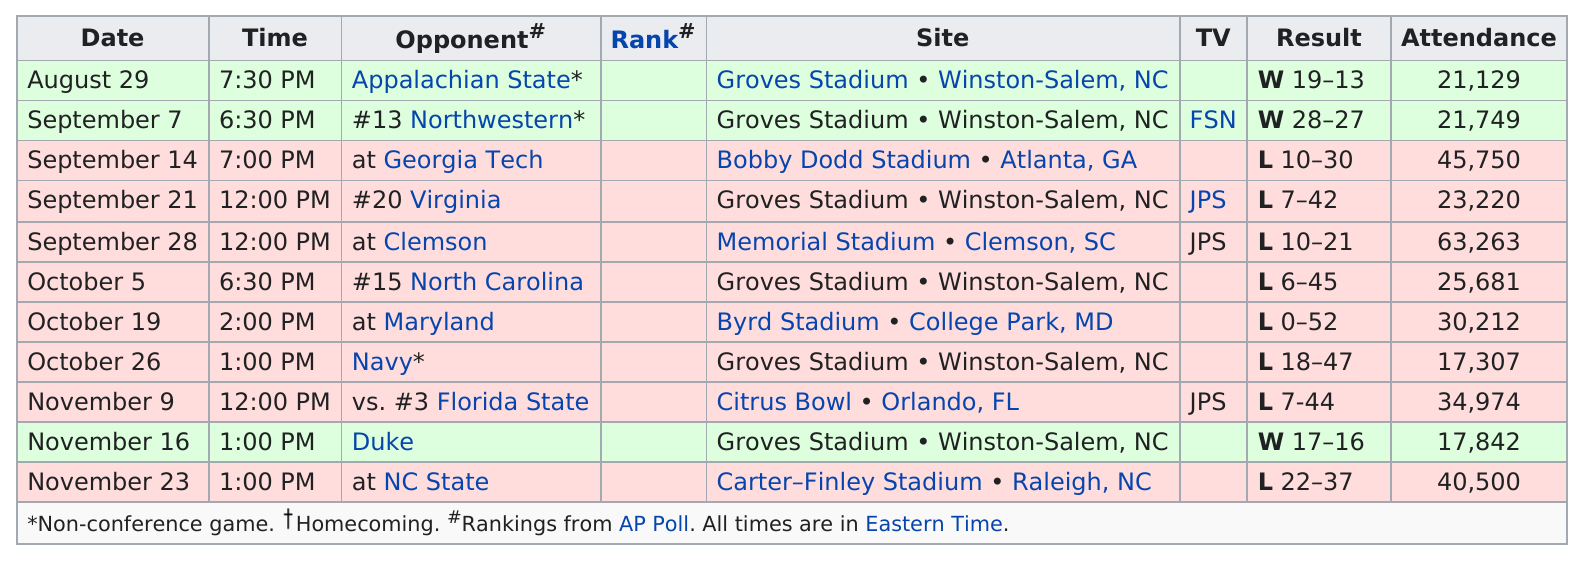Mention a couple of crucial points in this snapshot. The game with the least attendance is Navy. There were a total of 8 losses in the season. In the month that had the most games played, September, there were a significant number of games played. The attendance was below 20,000 for the first time on October 26. The attendance is over 30,000 more than 5 times. 